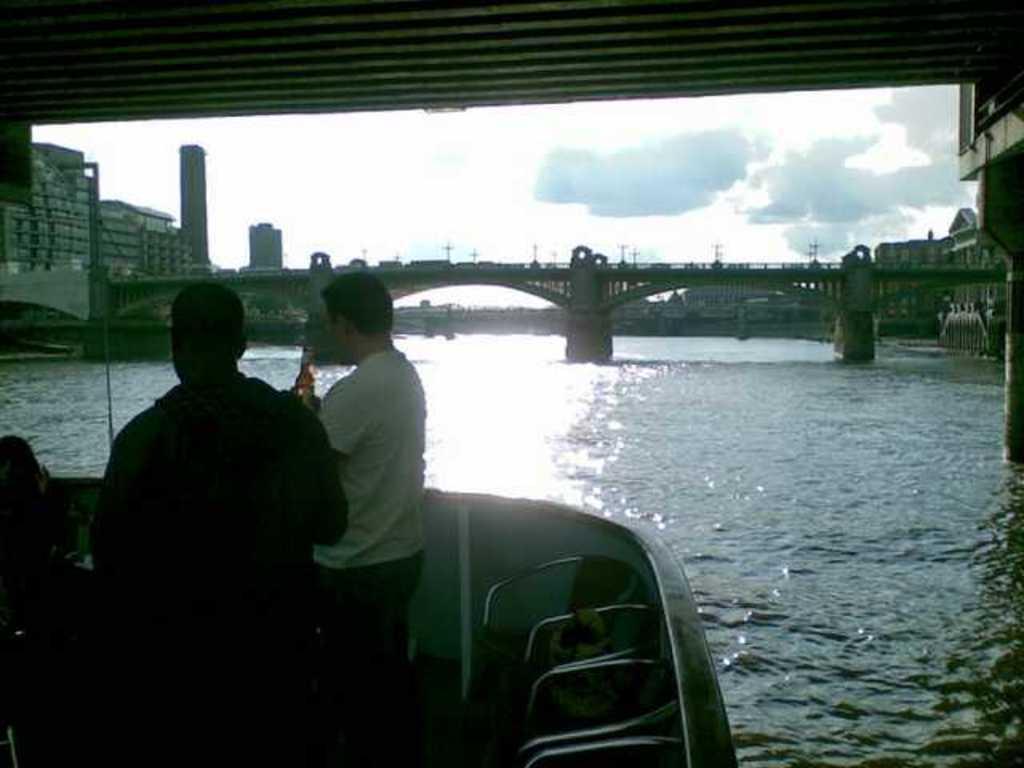Can you describe this image briefly? In this picture we can see there are two people on the boat and the boat is on the water. Behind the boat there is a bridge, buildings and the sky. 